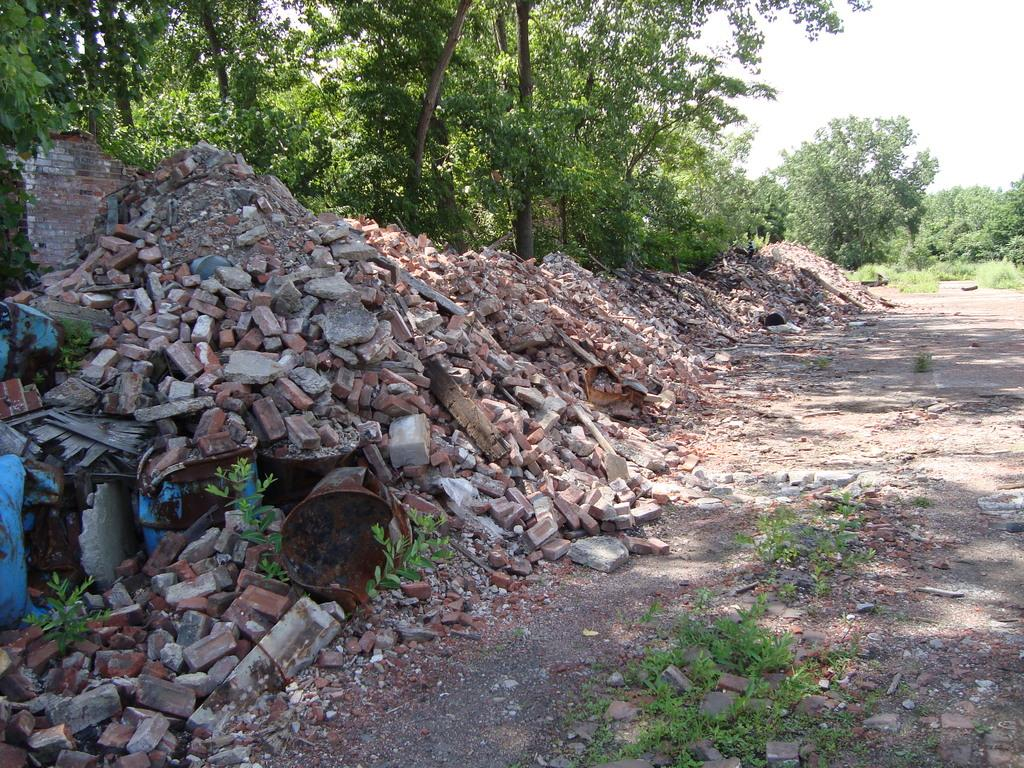What type of building material can be seen in the image? There are bricks in the image. What type of living organisms are present in the image? There are plants and trees visible in the image. What other objects can be seen in the image besides bricks and plants? There are other objects in the image. What part of the natural environment is visible in the image? The sky is visible in the image. Can you tell me how many times the grandfather kissed the lip in the image? There is no mention of a grandfather or a lip in the image, so this question cannot be answered. What type of attraction is depicted in the image? There is no attraction present in the image; it features bricks, plants, trees, and other objects. 